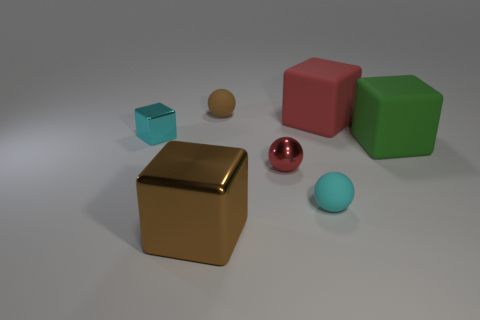Subtract all yellow cubes. Subtract all blue balls. How many cubes are left? 4 Add 3 big brown shiny things. How many objects exist? 10 Subtract all blocks. How many objects are left? 3 Subtract 1 brown cubes. How many objects are left? 6 Subtract all big gray matte cylinders. Subtract all tiny brown rubber spheres. How many objects are left? 6 Add 2 red objects. How many red objects are left? 4 Add 4 cyan matte things. How many cyan matte things exist? 5 